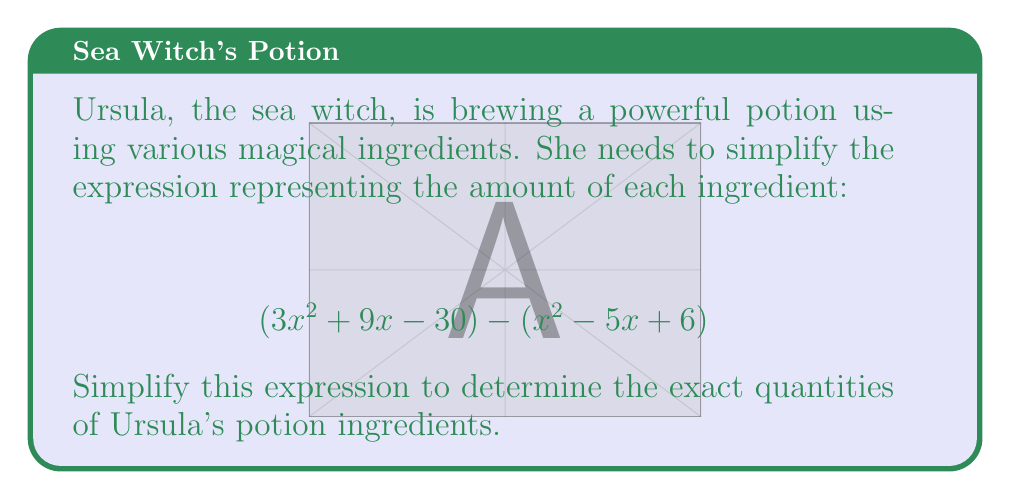Give your solution to this math problem. Let's simplify this expression step by step:

1) First, we need to subtract the second polynomial from the first. To do this, we'll subtract each term of the second polynomial from the corresponding term of the first polynomial.

2) The expression becomes:
   $$(3x^2 + 9x - 30) - (x^2 - 5x + 6)$$
   $$= 3x^2 + 9x - 30 - x^2 + 5x - 6$$

3) Now, we can rearrange the terms, grouping like terms together:
   $$= (3x^2 - x^2) + (9x + 5x) + (-30 - 6)$$

4) Simplify by combining like terms:
   $$= 2x^2 + 14x - 36$$

5) This is the simplified form of the expression. We can't factor it further as it doesn't have any common factors and it's not a perfect square trinomial or the difference of squares.

Thus, Ursula's potion ingredients are represented by the simplified expression $2x^2 + 14x - 36$.
Answer: $$2x^2 + 14x - 36$$ 